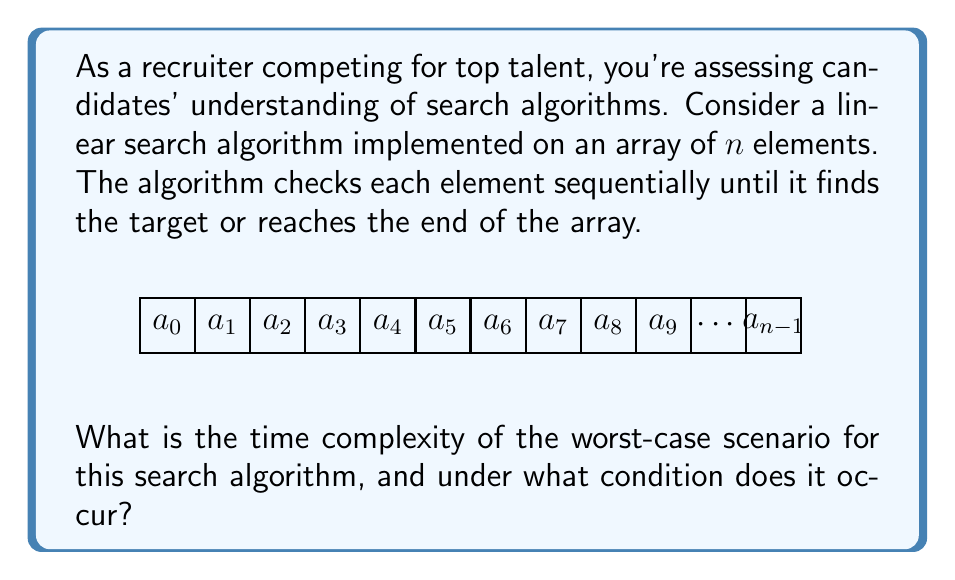Can you answer this question? To determine the worst-case scenario for a linear search algorithm, we need to consider the following steps:

1) The linear search algorithm checks each element of the array sequentially until it finds the target element or reaches the end of the array.

2) In the best-case scenario, the target element is found at the first position, resulting in $O(1)$ time complexity.

3) However, for the worst-case scenario, we need to consider two possibilities:
   a) The target element is at the last position of the array.
   b) The target element is not in the array at all.

4) In both cases (a) and (b), the algorithm needs to check every element of the array exactly once.

5) The number of comparisons made is equal to the number of elements in the array, which is $n$.

6) Therefore, the time complexity is directly proportional to the size of the input, $n$.

7) In Big O notation, this is expressed as $O(n)$, which represents linear time complexity.

8) The worst-case scenario occurs when:
   - The target element is at the last position of the array, or
   - The target element is not present in the array at all.

In both these cases, the algorithm must traverse the entire array, performing $n$ comparisons.
Answer: $O(n)$, when target is last or absent 